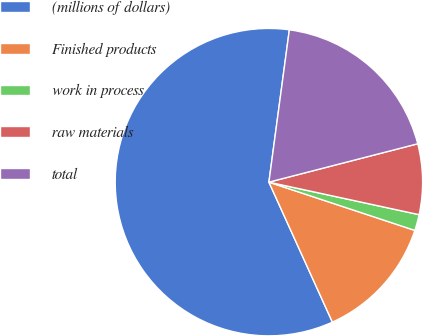Convert chart. <chart><loc_0><loc_0><loc_500><loc_500><pie_chart><fcel>(millions of dollars)<fcel>Finished products<fcel>work in process<fcel>raw materials<fcel>total<nl><fcel>58.9%<fcel>13.14%<fcel>1.69%<fcel>7.41%<fcel>18.86%<nl></chart> 